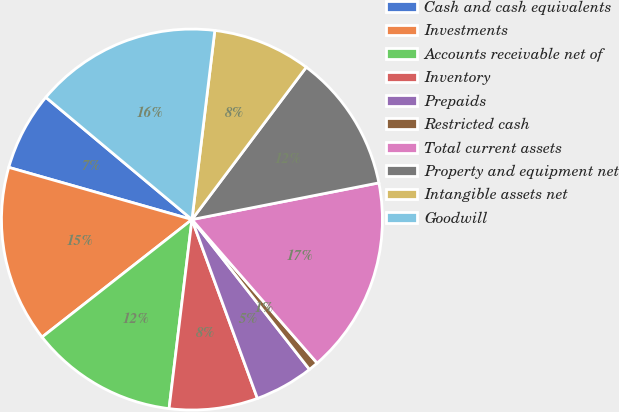Convert chart to OTSL. <chart><loc_0><loc_0><loc_500><loc_500><pie_chart><fcel>Cash and cash equivalents<fcel>Investments<fcel>Accounts receivable net of<fcel>Inventory<fcel>Prepaids<fcel>Restricted cash<fcel>Total current assets<fcel>Property and equipment net<fcel>Intangible assets net<fcel>Goodwill<nl><fcel>6.67%<fcel>15.0%<fcel>12.5%<fcel>7.5%<fcel>5.0%<fcel>0.83%<fcel>16.67%<fcel>11.67%<fcel>8.33%<fcel>15.83%<nl></chart> 